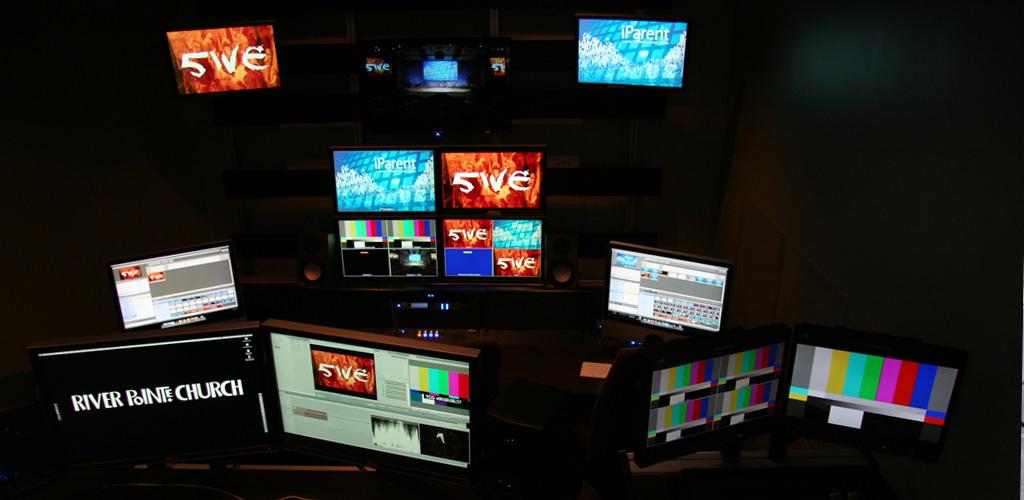Whats the name of the church?
Your answer should be compact. River pointe. What number is referenced on the orange monitor?
Offer a very short reply. 5. 